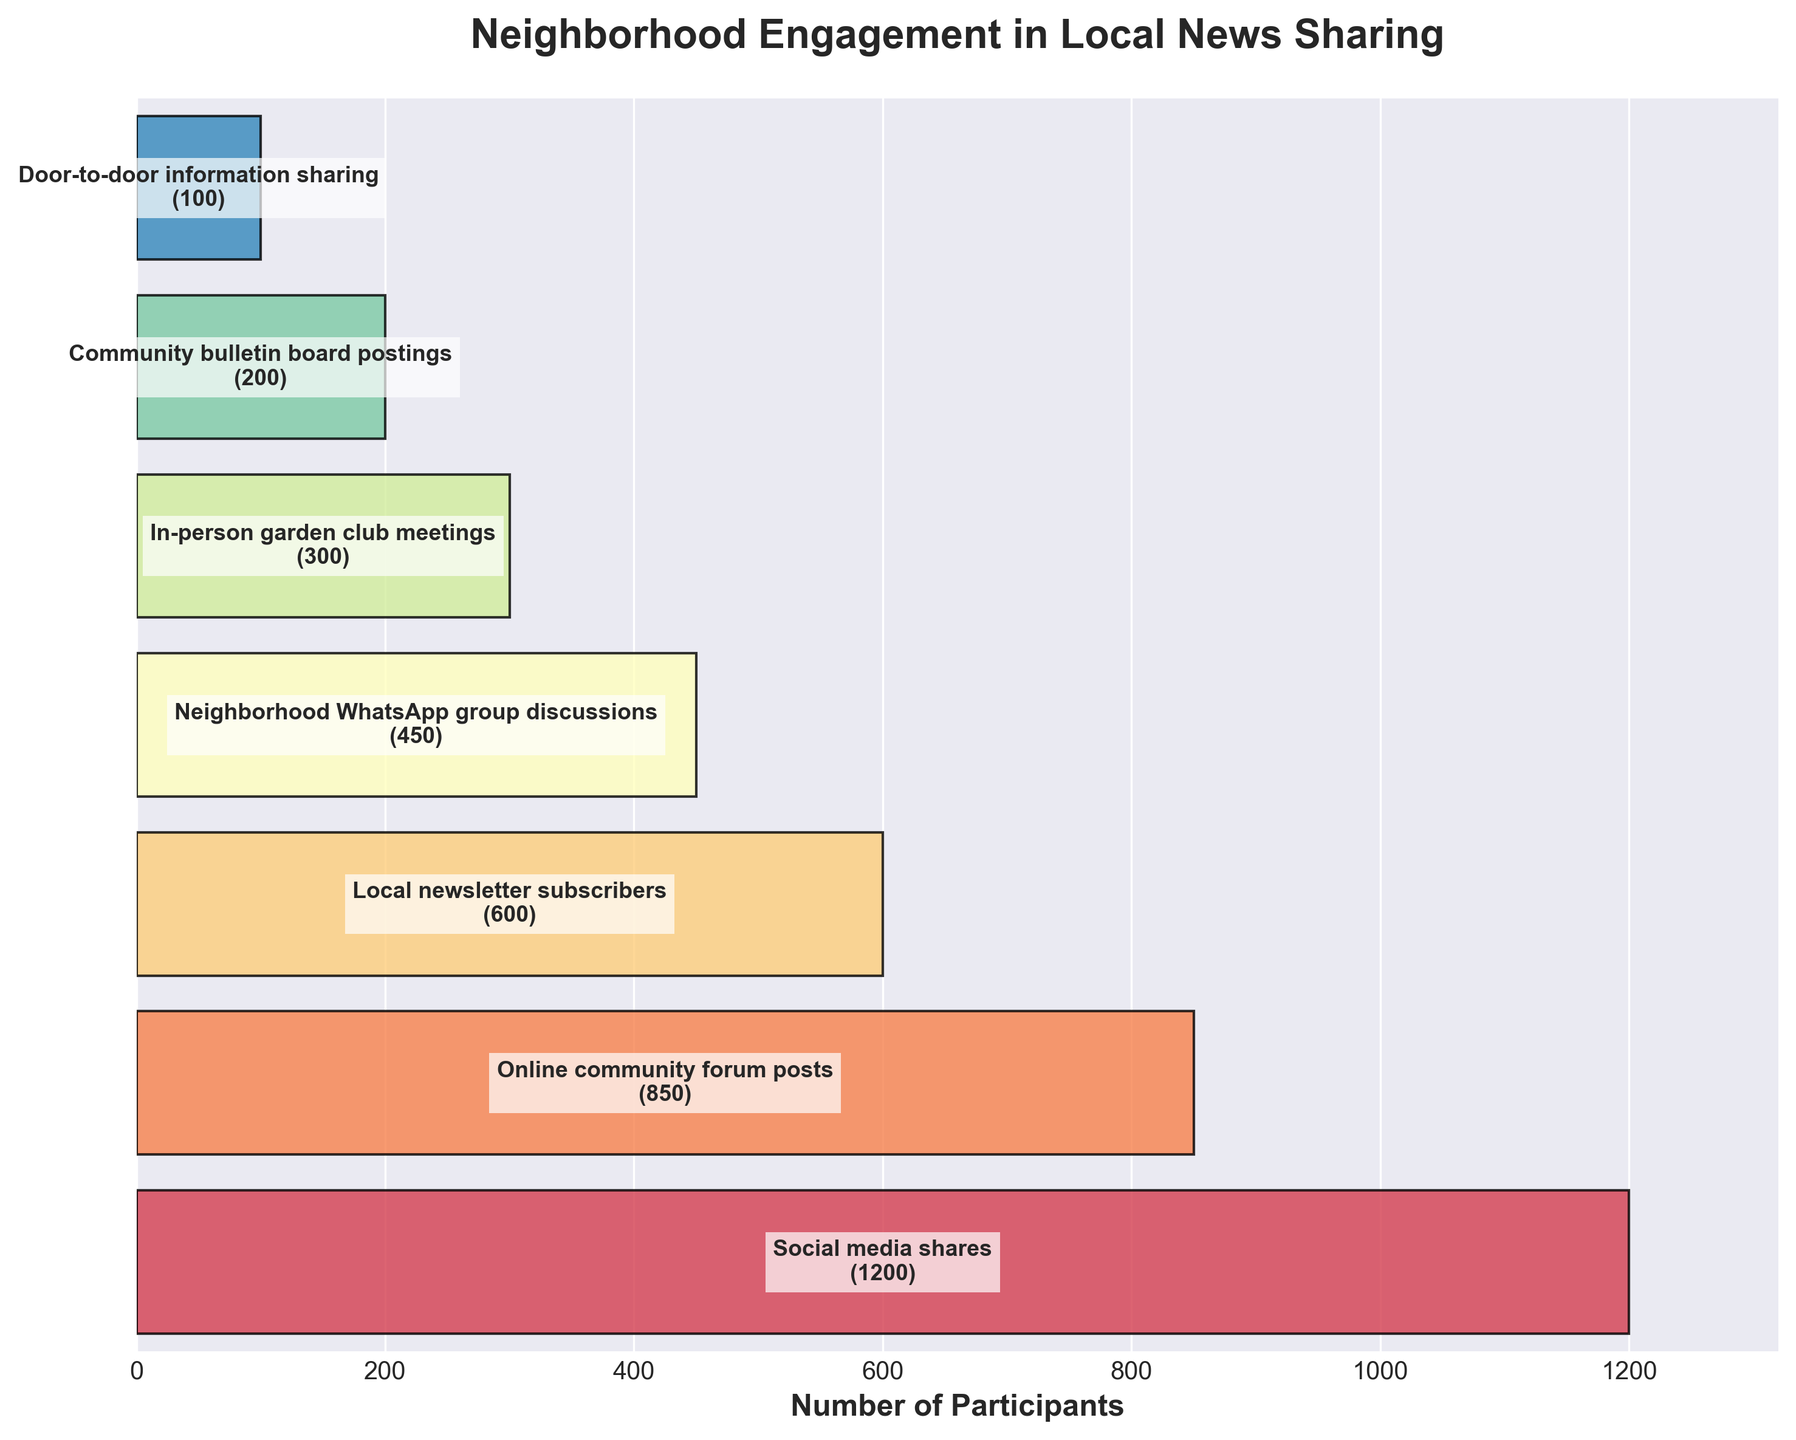How many participants are involved in 'Online community forum posts'? Locate the 'Online community forum posts' stage on the funnel chart and note the number of participants labeled next to it.
Answer: 850 What is the total number of participants for all stages combined? Sum the number of participants for all stages: 1200 + 850 + 600 + 450 + 300 + 200 + 100 = 3700
Answer: 3700 Which stage has the fewest participants? Identify the stage with the lowest number of participants by comparing all values in the funnel chart. 'Door-to-door information sharing' has the fewest participants (100).
Answer: 'Door-to-door information sharing' How many more participants are there in 'Social media shares' compared to 'In-person garden club meetings'? Subtract the number of participants in 'In-person garden club meetings' from those in 'Social media shares': 1200 - 300 = 900
Answer: 900 What is the ratio of participants in 'Neighborhood WhatsApp group discussions' to those in 'Community bulletin board postings'? Calculate the ratio by dividing the number of participants in 'Neighborhood WhatsApp group discussions' by the number in 'Community bulletin board postings': 450 / 200 = 2.25
Answer: 2.25 Which stage represents the midpoint of participant count when ordered from most to least participants? Arrange the stages in descending order of participants and find the midpoint: 'Social media shares' (1200), 'Online community forum posts' (850), 'Local newsletter subscribers' (600), 'Neighborhood WhatsApp group discussions' (450), 'In-person garden club meetings' (300), 'Community bulletin board postings' (200), 'Door-to-door information sharing' (100). The stage at the midpoint is 'Neighborhood WhatsApp group discussions' (450).
Answer: 'Neighborhood WhatsApp group discussions' How is the engagement trend from social media to door-to-door information sharing? Evaluate the direction of participant numbers from the top (Social media shares) to the bottom (Door-to-door information sharing) of the funnel chart. The trend shows a steady decrease in participant numbers.
Answer: Decreasing If the number of 'Community bulletin board postings' participants doubled, would it exceed 'In-person garden club meetings' participants? Double the number of participants in 'Community bulletin board postings' (200 * 2 = 400) and compare it to the number of participants in 'In-person garden club meetings' (300). Since 400 is greater than 300, it would exceed.
Answer: Yes What percentage of the total number of participants does the 'Local newsletter subscribers' stage represent? First, find the total number of participants (3700). Then, calculate the percentage: (600 / 3700) * 100 ≈ 16.22%
Answer: 16.22% 